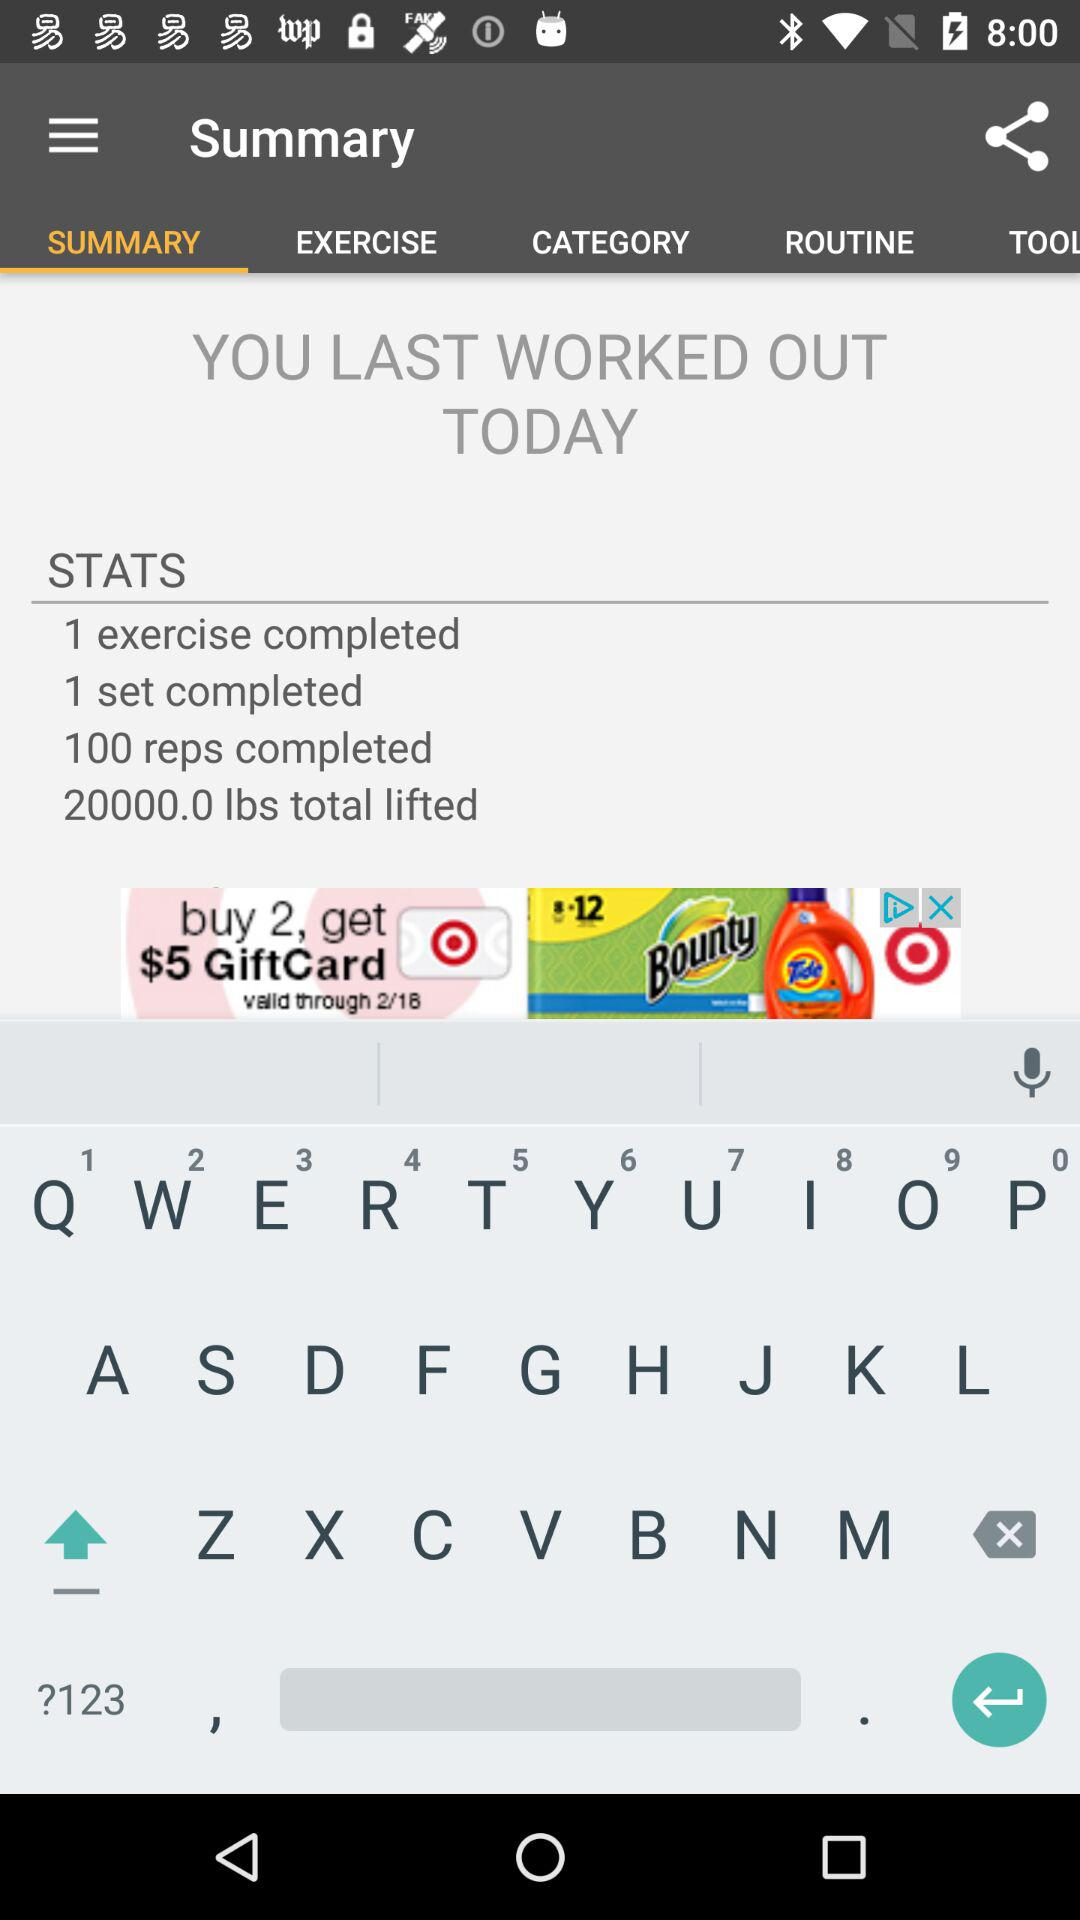What exercise did I do for my workout? The summary screen on the app doesn't specify the exercise, but it shows that you completed one exercise, for which you did 100 reps. 